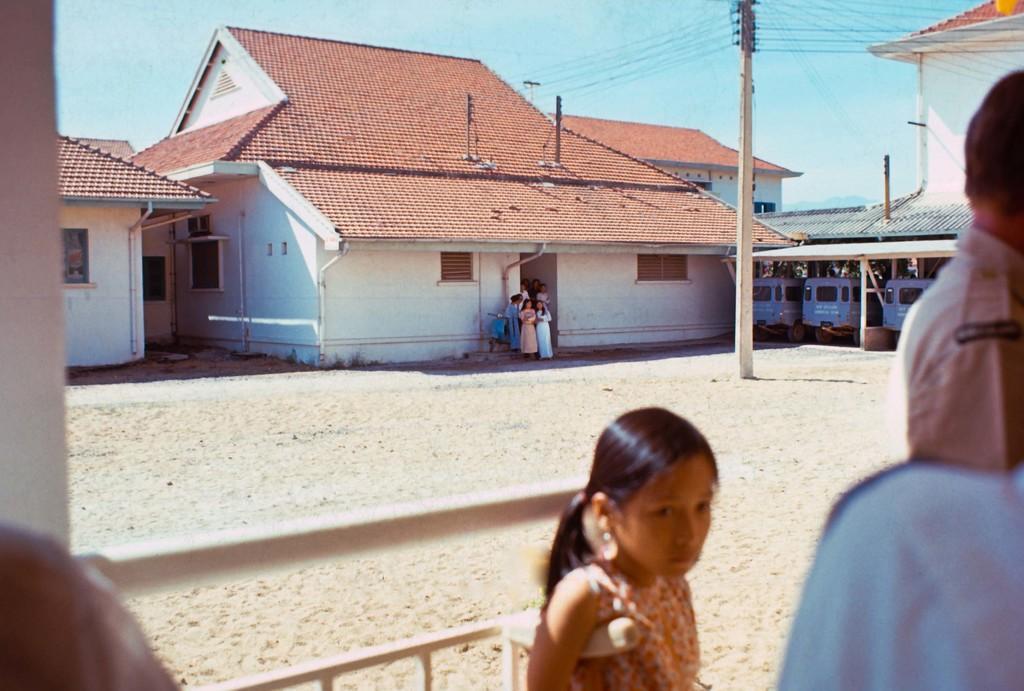Describe this image in one or two sentences. In this image there are two men on the right side, on the left side there is a man, in the middle there is a girl, in the background there are houses in that houses there are people, beside the house there is a shed in that shed their are vehicles in the middle there is a ground in that ground there is an electrical pole and there is a sky. 